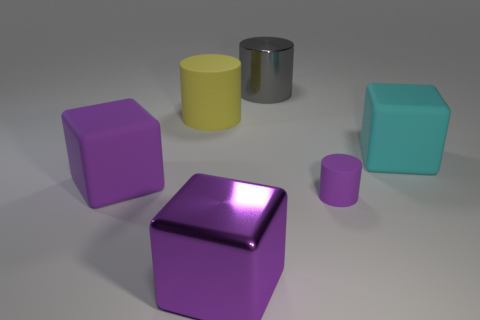There is a rubber block that is the same color as the small rubber cylinder; what size is it?
Keep it short and to the point. Large. The thing that is behind the matte cylinder behind the large cyan matte block is what shape?
Offer a terse response. Cylinder. How big is the purple thing that is both to the left of the small thing and behind the big purple metallic cube?
Your answer should be compact. Large. Is the shape of the big purple metal object the same as the big matte object on the right side of the yellow matte cylinder?
Make the answer very short. Yes. What size is the other rubber object that is the same shape as the tiny thing?
Keep it short and to the point. Large. There is a metal block; is it the same color as the matte block that is on the left side of the shiny cylinder?
Your answer should be very brief. Yes. What number of other things are the same size as the cyan block?
Your answer should be compact. 4. What shape is the large purple object in front of the matte block in front of the matte object that is to the right of the small purple matte cylinder?
Your response must be concise. Cube. There is a cyan thing; is its size the same as the cylinder that is to the left of the large gray shiny cylinder?
Offer a terse response. Yes. The cylinder that is behind the cyan thing and in front of the gray metal object is what color?
Your response must be concise. Yellow. 